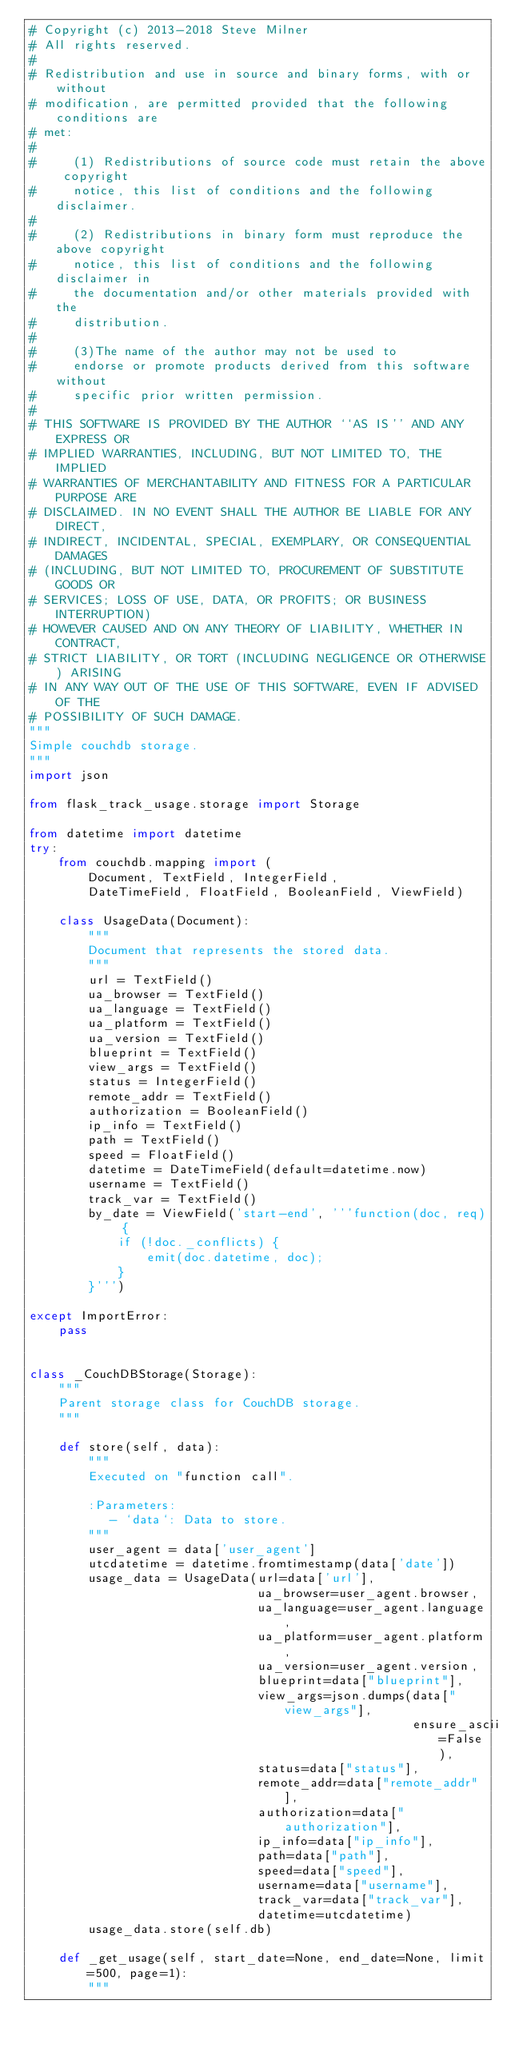Convert code to text. <code><loc_0><loc_0><loc_500><loc_500><_Python_># Copyright (c) 2013-2018 Steve Milner
# All rights reserved.
#
# Redistribution and use in source and binary forms, with or without
# modification, are permitted provided that the following conditions are
# met:
#
#     (1) Redistributions of source code must retain the above copyright
#     notice, this list of conditions and the following disclaimer.
#
#     (2) Redistributions in binary form must reproduce the above copyright
#     notice, this list of conditions and the following disclaimer in
#     the documentation and/or other materials provided with the
#     distribution.
#
#     (3)The name of the author may not be used to
#     endorse or promote products derived from this software without
#     specific prior written permission.
#
# THIS SOFTWARE IS PROVIDED BY THE AUTHOR ``AS IS'' AND ANY EXPRESS OR
# IMPLIED WARRANTIES, INCLUDING, BUT NOT LIMITED TO, THE IMPLIED
# WARRANTIES OF MERCHANTABILITY AND FITNESS FOR A PARTICULAR PURPOSE ARE
# DISCLAIMED. IN NO EVENT SHALL THE AUTHOR BE LIABLE FOR ANY DIRECT,
# INDIRECT, INCIDENTAL, SPECIAL, EXEMPLARY, OR CONSEQUENTIAL DAMAGES
# (INCLUDING, BUT NOT LIMITED TO, PROCUREMENT OF SUBSTITUTE GOODS OR
# SERVICES; LOSS OF USE, DATA, OR PROFITS; OR BUSINESS INTERRUPTION)
# HOWEVER CAUSED AND ON ANY THEORY OF LIABILITY, WHETHER IN CONTRACT,
# STRICT LIABILITY, OR TORT (INCLUDING NEGLIGENCE OR OTHERWISE) ARISING
# IN ANY WAY OUT OF THE USE OF THIS SOFTWARE, EVEN IF ADVISED OF THE
# POSSIBILITY OF SUCH DAMAGE.
"""
Simple couchdb storage.
"""
import json

from flask_track_usage.storage import Storage

from datetime import datetime
try:
    from couchdb.mapping import (
        Document, TextField, IntegerField,
        DateTimeField, FloatField, BooleanField, ViewField)

    class UsageData(Document):
        """
        Document that represents the stored data.
        """
        url = TextField()
        ua_browser = TextField()
        ua_language = TextField()
        ua_platform = TextField()
        ua_version = TextField()
        blueprint = TextField()
        view_args = TextField()
        status = IntegerField()
        remote_addr = TextField()
        authorization = BooleanField()
        ip_info = TextField()
        path = TextField()
        speed = FloatField()
        datetime = DateTimeField(default=datetime.now)
        username = TextField()
        track_var = TextField()
        by_date = ViewField('start-end', '''function(doc, req) {
            if (!doc._conflicts) {
                emit(doc.datetime, doc);
            }
        }''')

except ImportError:
    pass


class _CouchDBStorage(Storage):
    """
    Parent storage class for CouchDB storage.
    """

    def store(self, data):
        """
        Executed on "function call".

        :Parameters:
           - `data`: Data to store.
        """
        user_agent = data['user_agent']
        utcdatetime = datetime.fromtimestamp(data['date'])
        usage_data = UsageData(url=data['url'],
                               ua_browser=user_agent.browser,
                               ua_language=user_agent.language,
                               ua_platform=user_agent.platform,
                               ua_version=user_agent.version,
                               blueprint=data["blueprint"],
                               view_args=json.dumps(data["view_args"],
                                                    ensure_ascii=False),
                               status=data["status"],
                               remote_addr=data["remote_addr"],
                               authorization=data["authorization"],
                               ip_info=data["ip_info"],
                               path=data["path"],
                               speed=data["speed"],
                               username=data["username"],
                               track_var=data["track_var"],
                               datetime=utcdatetime)
        usage_data.store(self.db)

    def _get_usage(self, start_date=None, end_date=None, limit=500, page=1):
        """</code> 